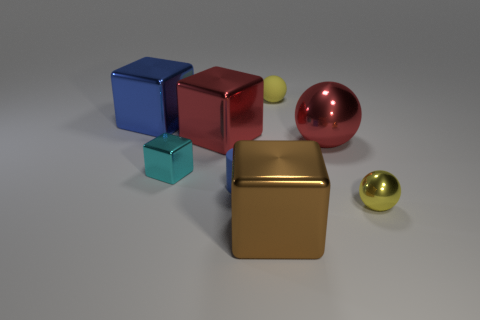How many red objects have the same shape as the tiny cyan metal object?
Your answer should be very brief. 1. Are the big blue block and the small cyan cube made of the same material?
Ensure brevity in your answer.  Yes. The small yellow object that is in front of the blue thing in front of the blue cube is what shape?
Your answer should be compact. Sphere. There is a big thing that is in front of the blue rubber cylinder; what number of rubber things are behind it?
Keep it short and to the point. 2. What material is the cube that is both in front of the large ball and behind the small yellow metallic thing?
Ensure brevity in your answer.  Metal. What shape is the blue rubber object that is the same size as the yellow rubber sphere?
Give a very brief answer. Cylinder. What is the color of the cube in front of the yellow thing in front of the cyan cube on the left side of the brown metallic block?
Your answer should be compact. Brown. What number of things are cubes that are on the left side of the large red cube or small rubber objects?
Provide a succinct answer. 4. What material is the blue cylinder that is the same size as the matte sphere?
Provide a short and direct response. Rubber. What material is the blue cylinder in front of the metallic ball on the left side of the yellow ball that is in front of the large red metallic ball made of?
Your answer should be compact. Rubber. 